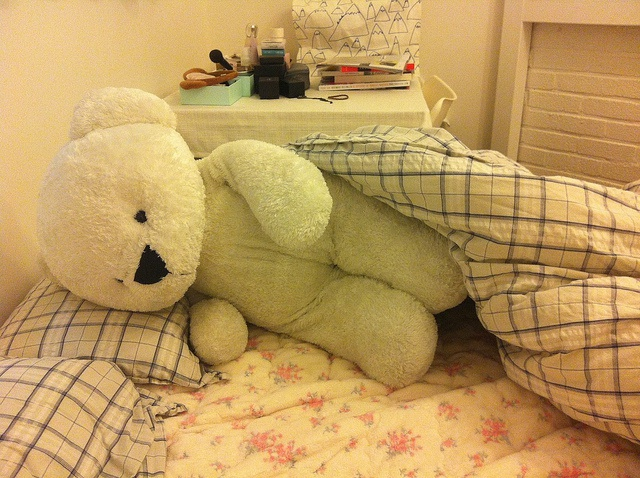Describe the objects in this image and their specific colors. I can see bed in tan and olive tones, teddy bear in tan, olive, and khaki tones, book in tan, gray, and maroon tones, book in tan and olive tones, and book in tan, gray, brown, and maroon tones in this image. 